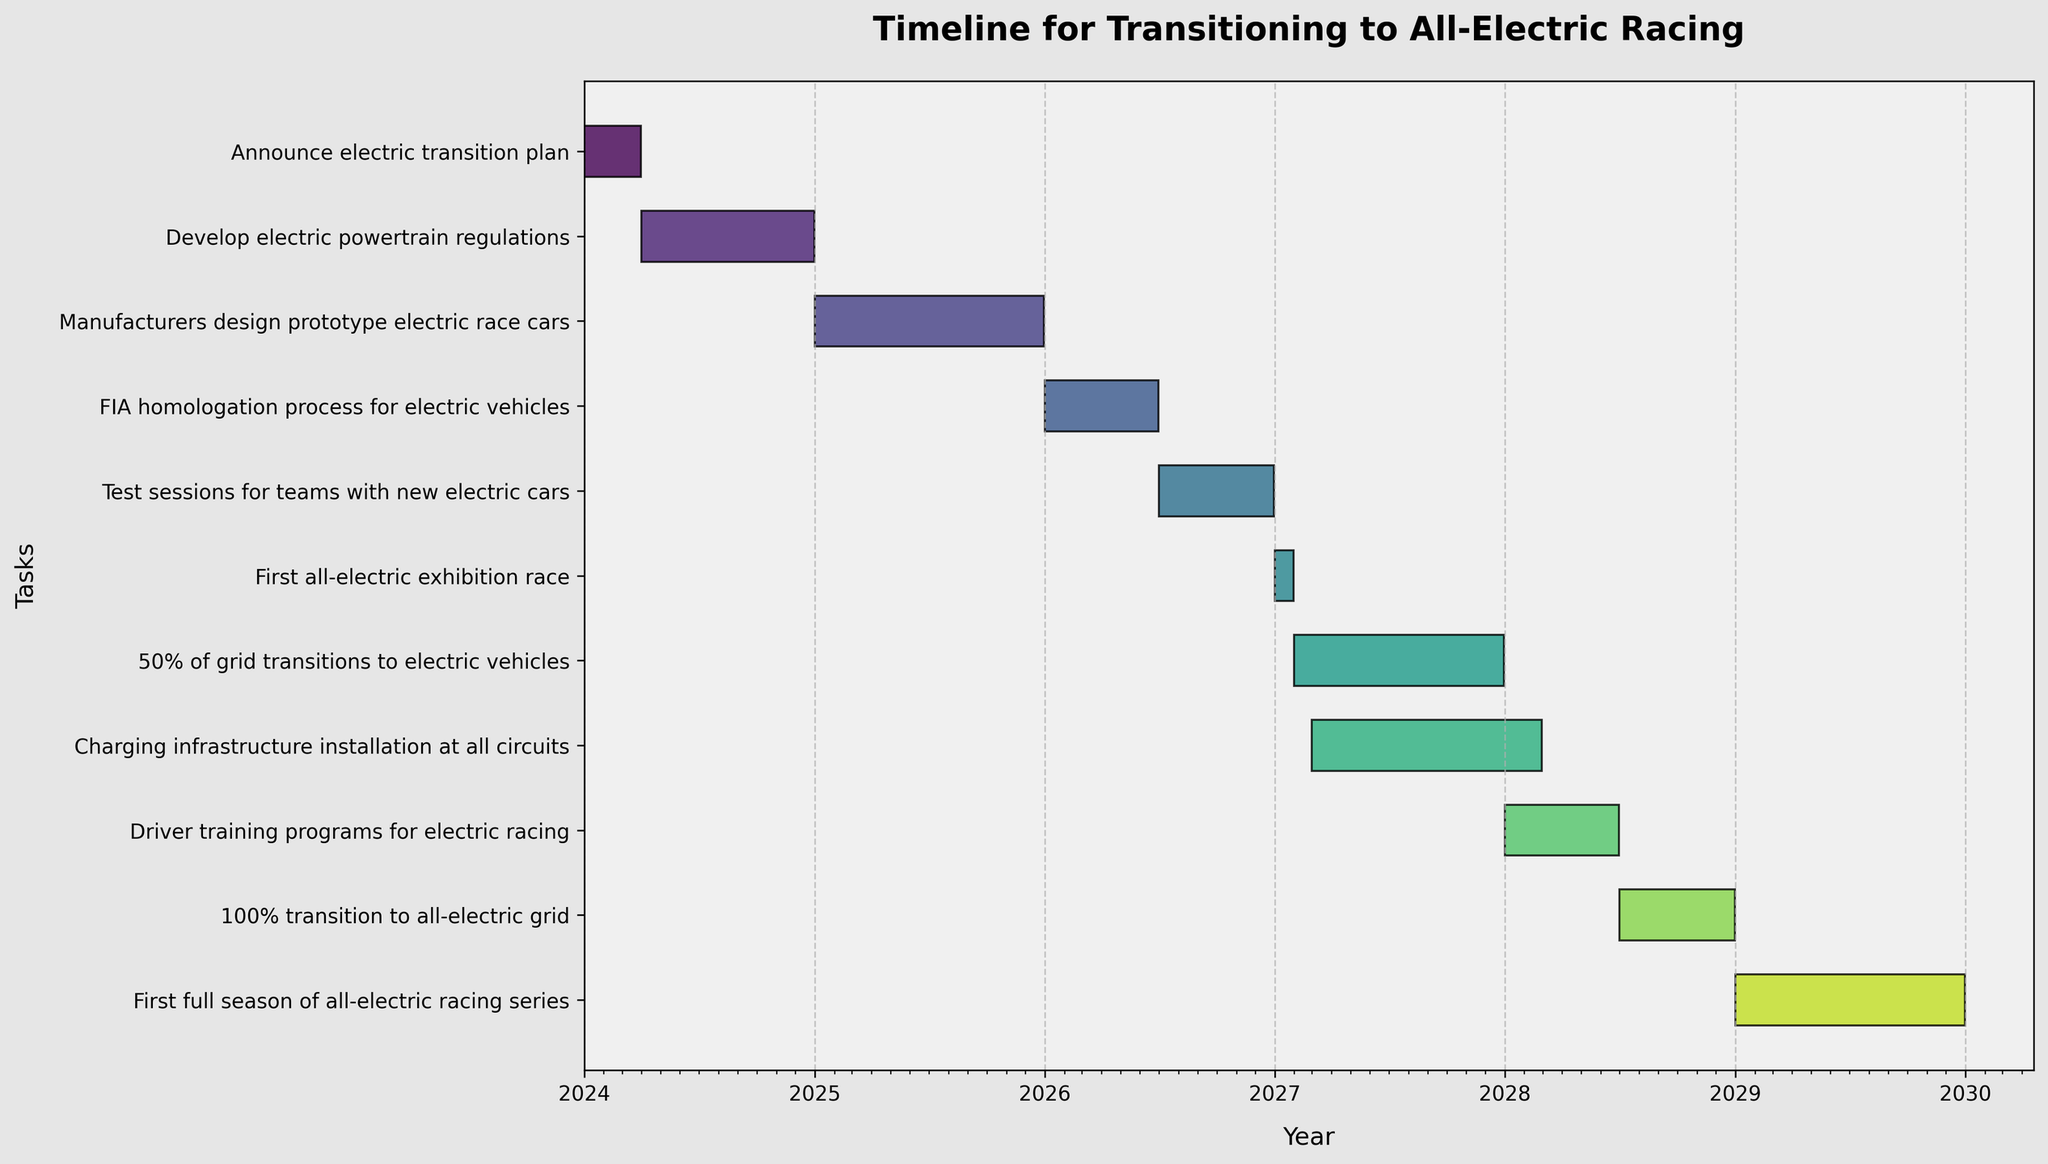What is the title of the Gantt Chart? The title is located at the top of the chart, indicating the main subject.
Answer: Timeline for Transitioning to All-Electric Racing When is the "First all-electric exhibition race" scheduled to occur? The timeline for each task is represented as a horizontal bar along the chart. For the "First all-electric exhibition race," find the corresponding bar and look at the start and end dates.
Answer: January 2027 How long will the "FIA homologation process for electric vehicles" take? Calculate the duration by looking at the start and end dates of the task and determining the time between them.
Answer: 6 months Which task has the longest duration, and what is its duration? Compare the lengths of all the task bars to find the longest one, then calculate its duration by looking at the start and end dates.
Answer: Charging infrastructure installation at all circuits, 12 months Which two tasks are scheduled to occur simultaneously in 2026? Look at the tasks scheduled for 2026 and see which ones overlap regarding their horizontal bars on the timeline.
Answer: FIA homologation process for electric vehicles and Test sessions for teams with new electric cars When will the full grid be transitioned to all-electric vehicles? Identify the task "100% transition to all-electric grid" and check the start and end dates to determine the time of completion.
Answer: December 2028 How many months in total does the timeline cover from the first to the last task? Determine the start date of the first task and the end date of the last task, then calculate the total number of months between these dates.
Answer: 72 months When is the task "Driver training programs for electric racing" scheduled? Find the bar labeled "Driver training programs for electric racing" and note its start and end dates.
Answer: January 2028 to June 2028 Which task ends at the start of 2029? Look for tasks with end dates around the beginning of 2029 to determine which one aligns.
Answer: 100% transition to all-electric grid What is the first task scheduled to begin in 2027, and what follows immediately after? Identify the task that starts first in 2027, and then look for the next task chronologically.
Answer: First all-electric exhibition race, followed by 50% of grid transitions to electric vehicles 